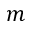<formula> <loc_0><loc_0><loc_500><loc_500>m</formula> 